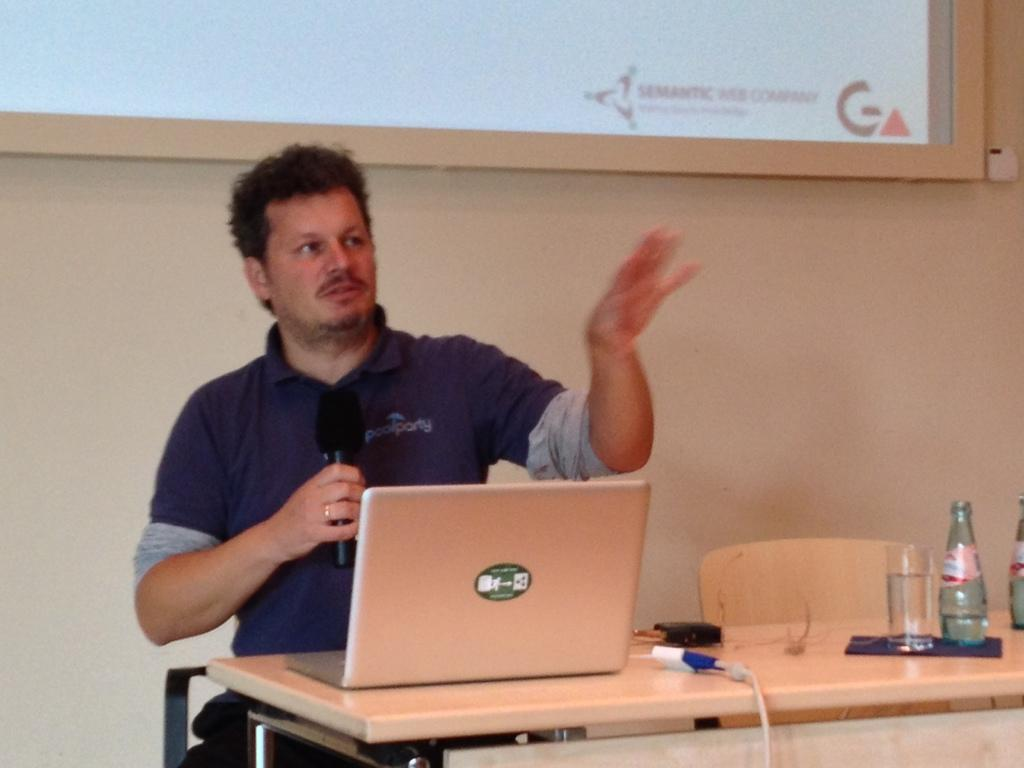<image>
Provide a brief description of the given image. a man next to an image with the word semantic on it 